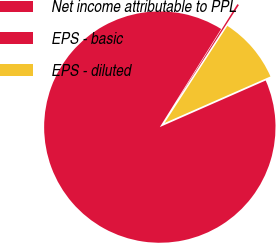Convert chart to OTSL. <chart><loc_0><loc_0><loc_500><loc_500><pie_chart><fcel>Net income attributable to PPL<fcel>EPS - basic<fcel>EPS - diluted<nl><fcel>90.49%<fcel>0.24%<fcel>9.27%<nl></chart> 